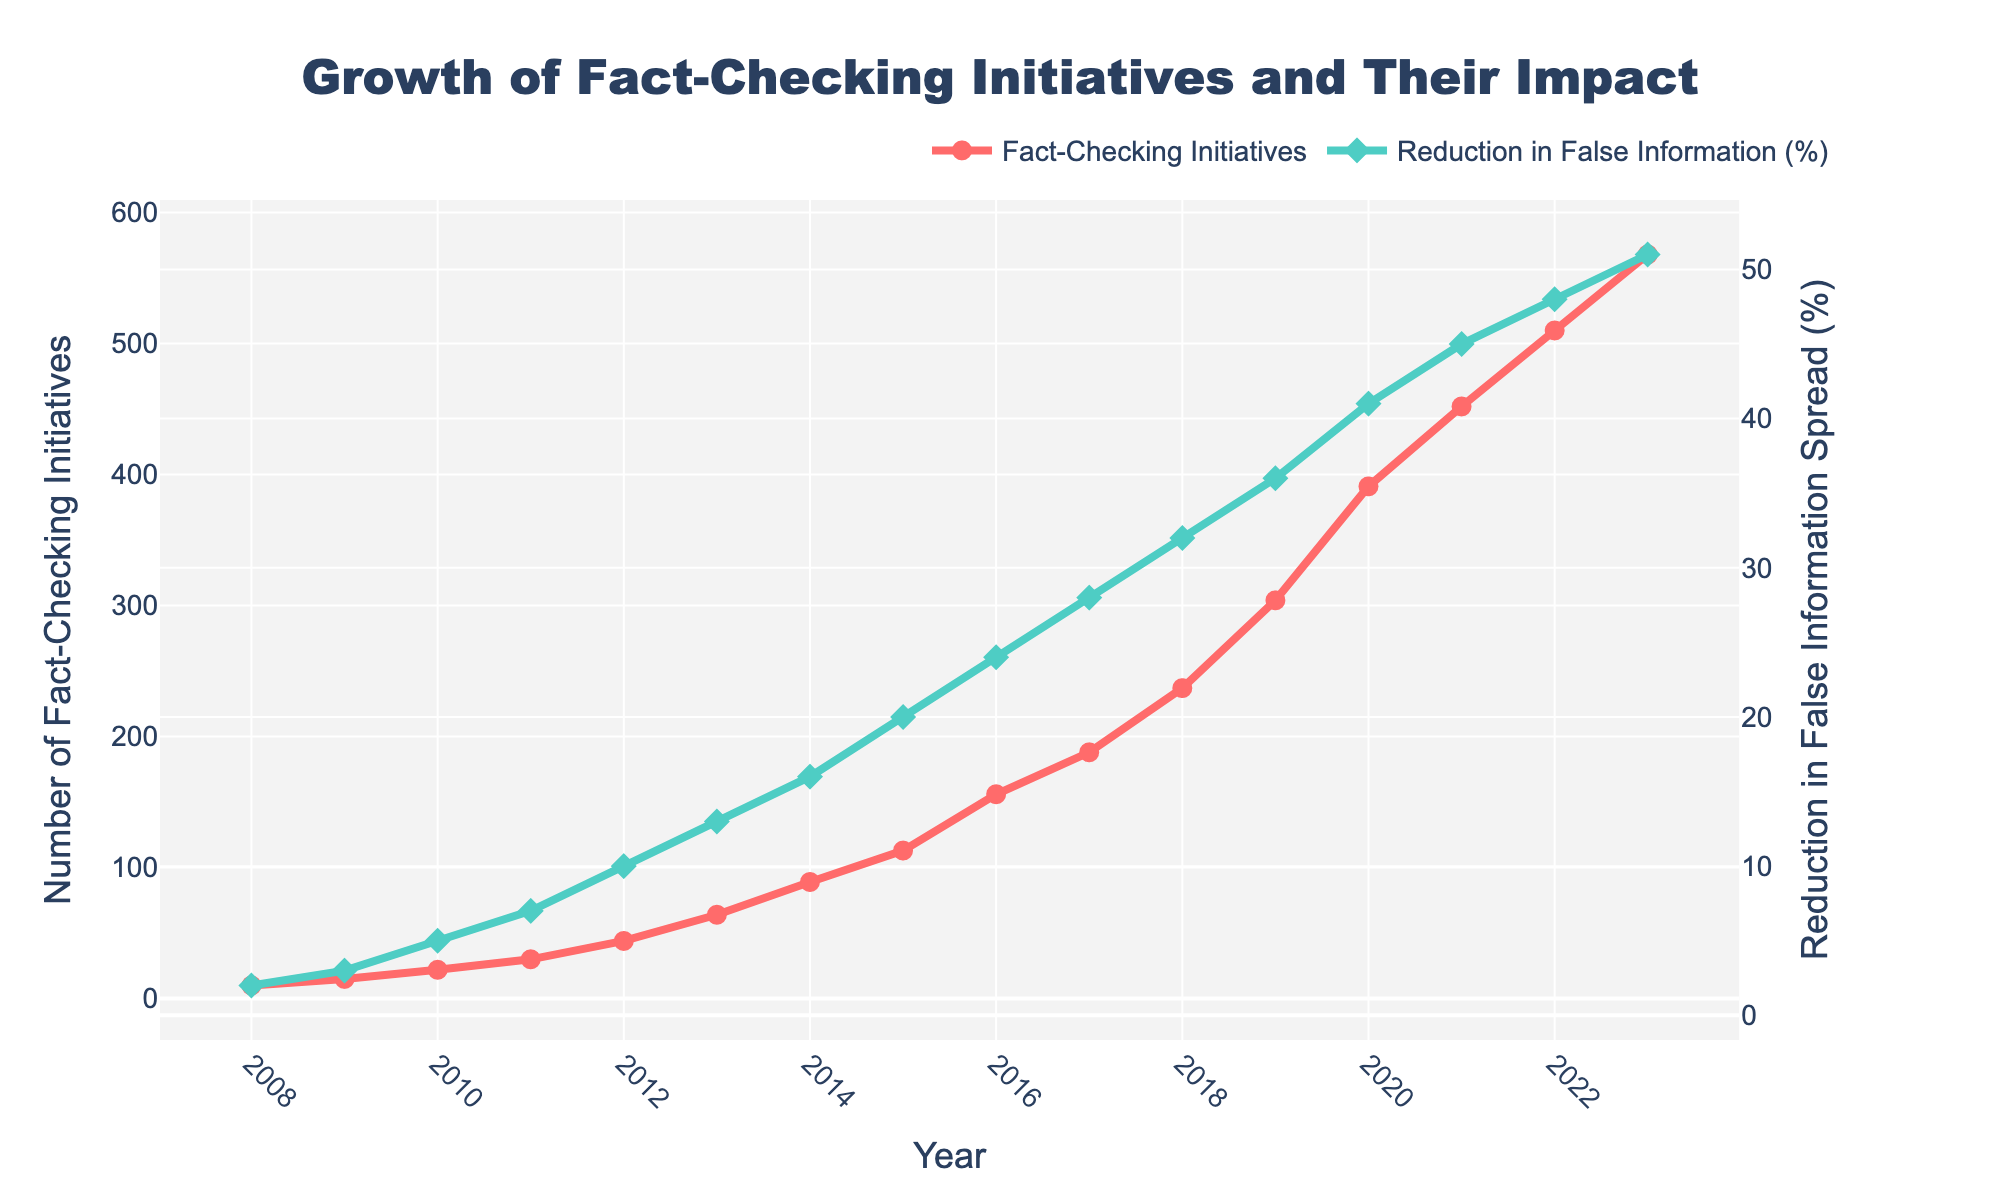What is the overall trend of the number of fact-checking initiatives from 2008 to 2023? The chart shows a consistent upward trend in the number of fact-checking initiatives, starting from 10 in 2008 and growing each year to reach 568 in 2023.
Answer: Upward trend How much has the reduction in false information spread increased between 2010 and 2019? In 2010, the reduction in false information spread was 5%. By 2019, it had increased to 36%. The increase is 36% - 5% = 31%.
Answer: 31% Which year had the greatest increase in the number of fact-checking initiatives compared to the previous year? Based on the figure, from 2019 to 2020, the number of fact-checking initiatives increased the most, from 304 to 391, an increase of 87.
Answer: 2019 to 2020 Between 2012 and 2015, how much did the number of fact-checking initiatives increase on average per year? From 2012 to 2015, the number of fact-checking initiatives increased from 44 to 113. The total increase over the 3 years is 113 - 44 = 69. The average annual increase is 69 / 3 ≈ 23.
Answer: 23 What color represents the reduction in false information spread in the chart? The reduction in false information spread is represented by a green line with diamonds.
Answer: Green What was the reduction in false information spread (%) in 2018, and how much did it increase by 2023? In 2018, the reduction in false information was 32%. By 2023, it increased to 51%, a difference of 51% - 32% = 19%.
Answer: 19% Do the number of fact-checking initiatives and the reduction in false information spread follow the same trend over the years? Both metrics show an increasing trend over the years, indicating that as the number of fact-checking initiatives increases, the reduction in false information spread also increases.
Answer: Yes Which year shows the first significant increase in the reduction of false information spread to over 10%? The year 2012 had the reduction of false information spread reaching 10%, indicating the first significant increase.
Answer: 2012 Between which consecutive years did the reduction in false information spread show the smallest increase? From 2008 to 2009, the reduction in false information spread increased only by 1% (from 2% to 3%).
Answer: 2008 to 2009 